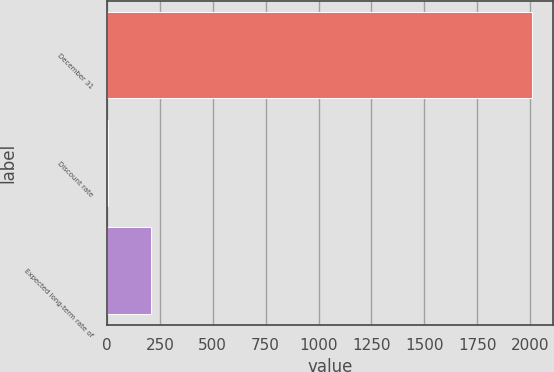<chart> <loc_0><loc_0><loc_500><loc_500><bar_chart><fcel>December 31<fcel>Discount rate<fcel>Expected long-term rate of<nl><fcel>2010<fcel>5.75<fcel>206.18<nl></chart> 